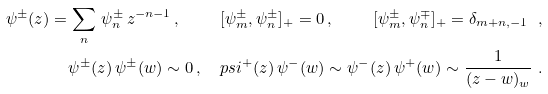Convert formula to latex. <formula><loc_0><loc_0><loc_500><loc_500>\psi ^ { \pm } ( z ) = \sum _ { n } \, \psi ^ { \pm } _ { n } \, z ^ { - n - 1 } \, , \quad \ [ \psi ^ { \pm } _ { m } , \psi ^ { \pm } _ { n } ] _ { + } = 0 \, , \quad \ [ \psi ^ { \pm } _ { m } , \psi ^ { \mp } _ { n } ] _ { + } = \delta _ { m + n , - 1 } \ , \\ \psi ^ { \pm } ( z ) \, \psi ^ { \pm } ( w ) \sim 0 \, , \quad p s i ^ { + } ( z ) \, \psi ^ { - } ( w ) \sim \psi ^ { - } ( z ) \, \psi ^ { + } ( w ) \sim \frac { 1 } { ( z - w ) _ { w } } \ .</formula> 